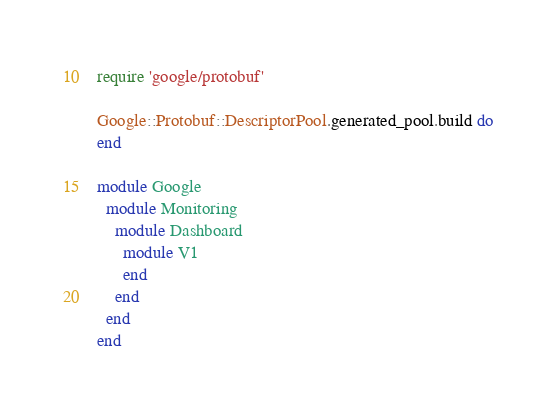<code> <loc_0><loc_0><loc_500><loc_500><_Ruby_>require 'google/protobuf'

Google::Protobuf::DescriptorPool.generated_pool.build do
end

module Google
  module Monitoring
    module Dashboard
      module V1
      end
    end
  end
end
</code> 